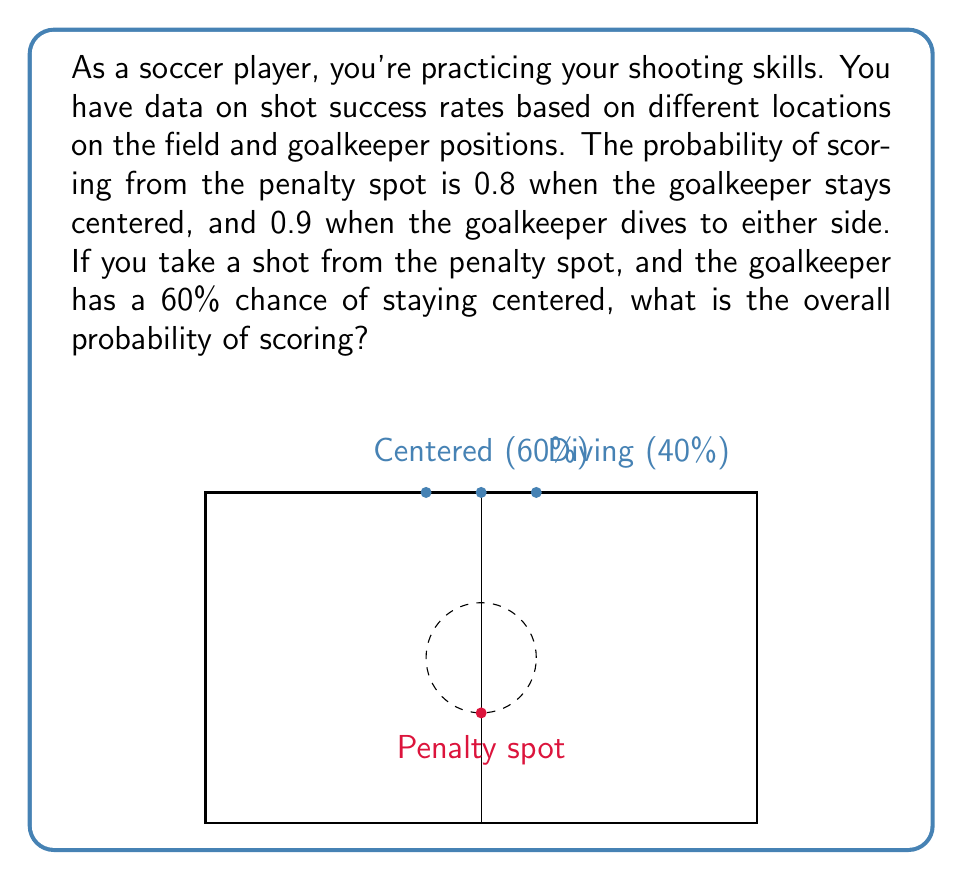Provide a solution to this math problem. Let's approach this step-by-step using the concept of total probability:

1) Define events:
   A: Scoring a goal
   B1: Goalkeeper stays centered
   B2: Goalkeeper dives to either side

2) Given probabilities:
   P(B1) = 0.60 (Goalkeeper stays centered)
   P(B2) = 1 - P(B1) = 0.40 (Goalkeeper dives)
   P(A|B1) = 0.80 (Probability of scoring when goalkeeper is centered)
   P(A|B2) = 0.90 (Probability of scoring when goalkeeper dives)

3) Use the law of total probability:
   P(A) = P(A|B1) * P(B1) + P(A|B2) * P(B2)

4) Substitute the values:
   P(A) = 0.80 * 0.60 + 0.90 * 0.40

5) Calculate:
   P(A) = 0.48 + 0.36 = 0.84

Therefore, the overall probability of scoring is 0.84 or 84%.
Answer: 0.84 